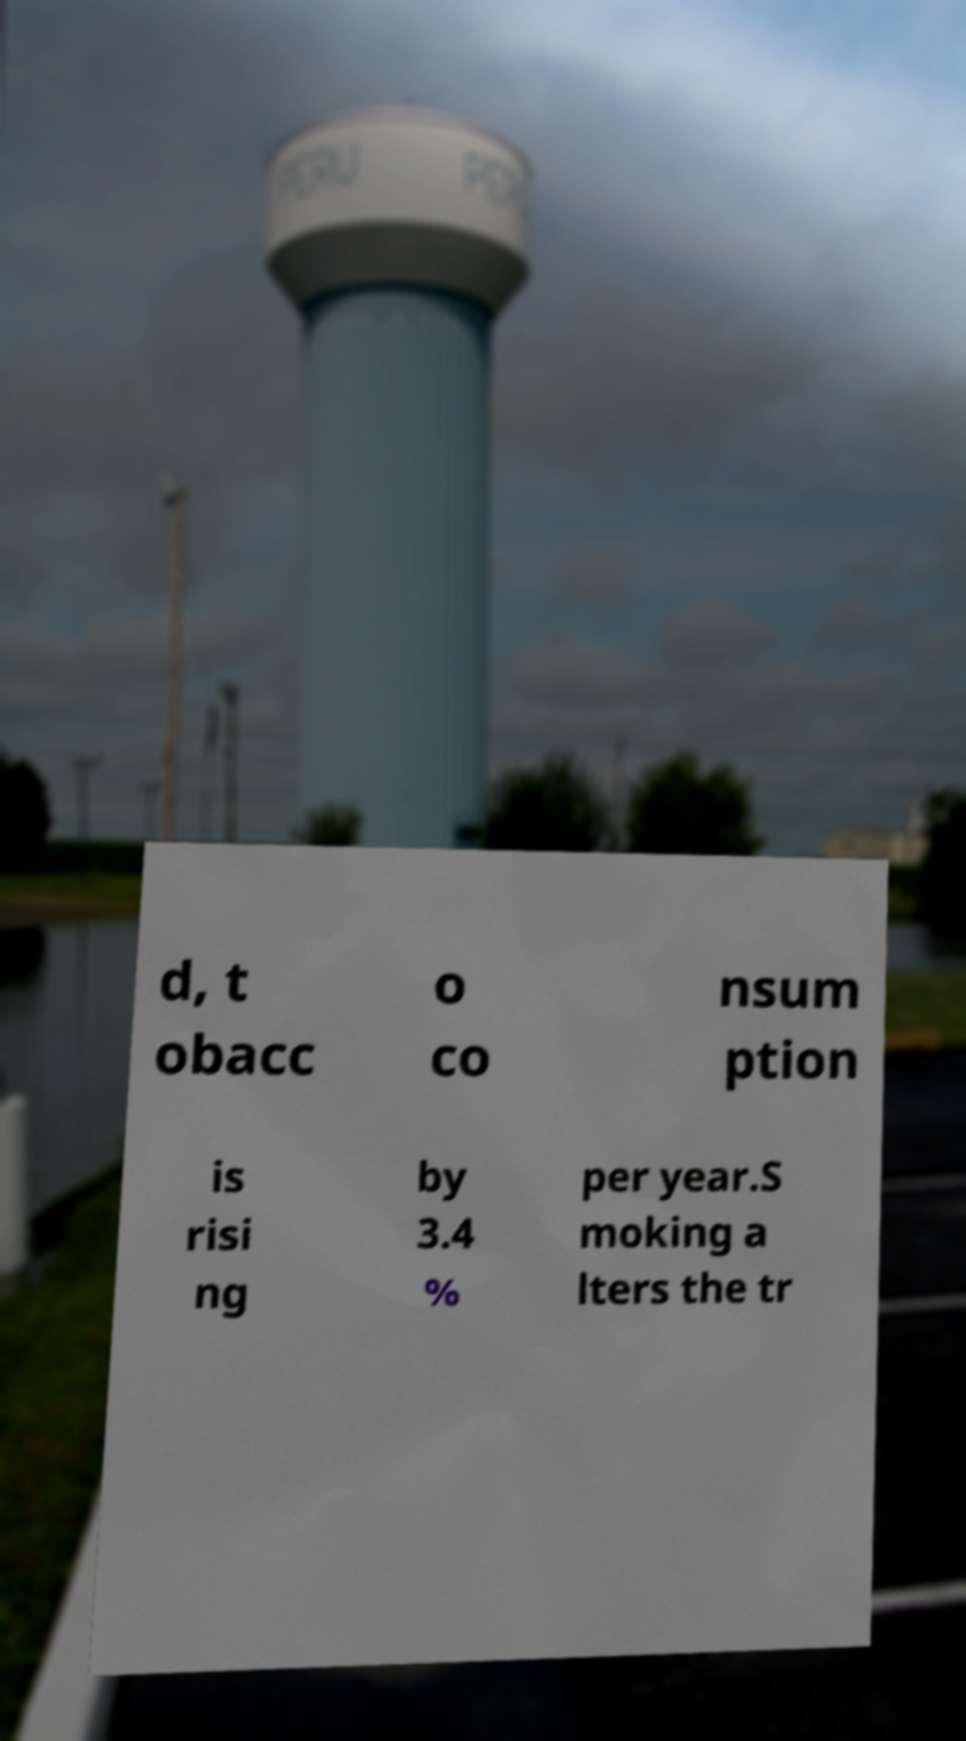Could you extract and type out the text from this image? d, t obacc o co nsum ption is risi ng by 3.4 % per year.S moking a lters the tr 